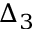Convert formula to latex. <formula><loc_0><loc_0><loc_500><loc_500>\Delta _ { 3 }</formula> 